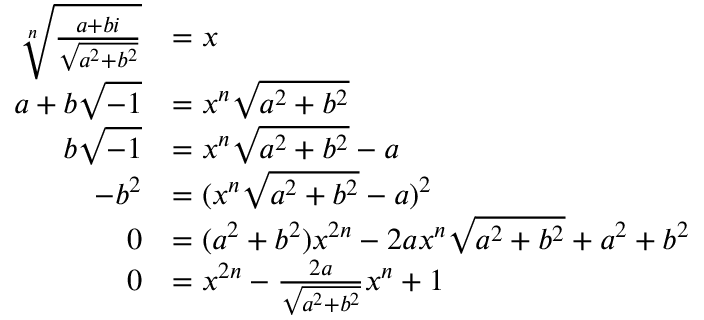<formula> <loc_0><loc_0><loc_500><loc_500>\begin{array} { r l } { \sqrt { [ } n ] { \frac { a + b i } { \sqrt { a ^ { 2 } + b ^ { 2 } } } } } & { = x } \\ { a + b \sqrt { - 1 } } & { = x ^ { n } \sqrt { a ^ { 2 } + b ^ { 2 } } } \\ { b \sqrt { - 1 } } & { = x ^ { n } \sqrt { a ^ { 2 } + b ^ { 2 } } - a } \\ { - b ^ { 2 } } & { = ( x ^ { n } \sqrt { a ^ { 2 } + b ^ { 2 } } - a ) ^ { 2 } } \\ { 0 } & { = ( a ^ { 2 } + b ^ { 2 } ) x ^ { 2 n } - 2 a x ^ { n } \sqrt { a ^ { 2 } + b ^ { 2 } } + a ^ { 2 } + b ^ { 2 } } \\ { 0 } & { = x ^ { 2 n } - \frac { 2 a } { \sqrt { a ^ { 2 } + b ^ { 2 } } } x ^ { n } + 1 } \end{array}</formula> 